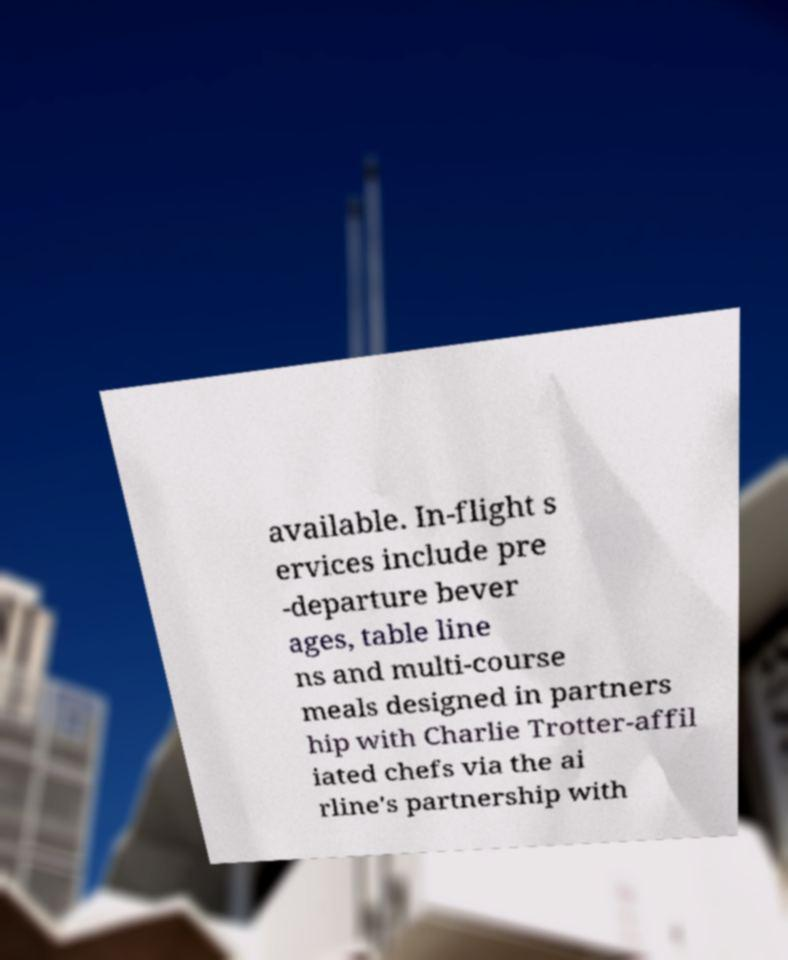I need the written content from this picture converted into text. Can you do that? available. In-flight s ervices include pre -departure bever ages, table line ns and multi-course meals designed in partners hip with Charlie Trotter-affil iated chefs via the ai rline's partnership with 